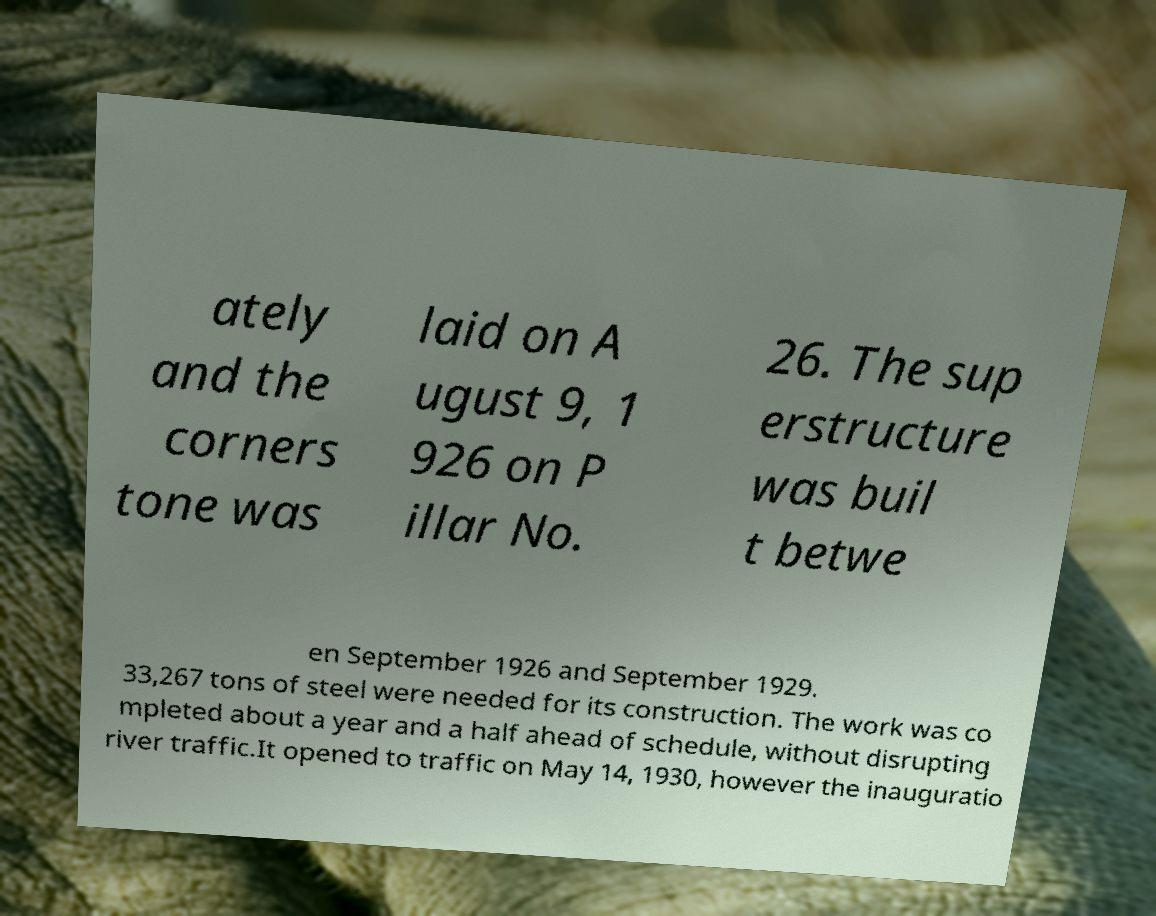Can you read and provide the text displayed in the image?This photo seems to have some interesting text. Can you extract and type it out for me? ately and the corners tone was laid on A ugust 9, 1 926 on P illar No. 26. The sup erstructure was buil t betwe en September 1926 and September 1929. 33,267 tons of steel were needed for its construction. The work was co mpleted about a year and a half ahead of schedule, without disrupting river traffic.It opened to traffic on May 14, 1930, however the inauguratio 